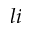<formula> <loc_0><loc_0><loc_500><loc_500>l i</formula> 